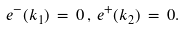<formula> <loc_0><loc_0><loc_500><loc_500>e ^ { - } ( k _ { 1 } ) \, = \, 0 \, , \, e ^ { + } ( k _ { 2 } ) \, = \, 0 .</formula> 